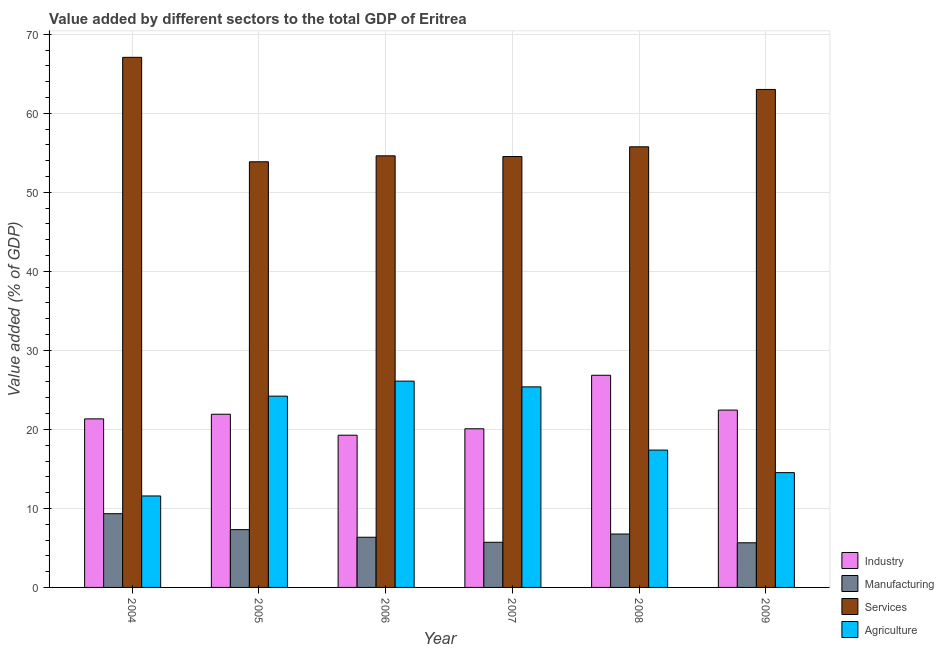How many different coloured bars are there?
Provide a short and direct response. 4. Are the number of bars per tick equal to the number of legend labels?
Offer a terse response. Yes. Are the number of bars on each tick of the X-axis equal?
Your response must be concise. Yes. What is the label of the 2nd group of bars from the left?
Give a very brief answer. 2005. What is the value added by manufacturing sector in 2006?
Your answer should be very brief. 6.35. Across all years, what is the maximum value added by manufacturing sector?
Make the answer very short. 9.33. Across all years, what is the minimum value added by manufacturing sector?
Your answer should be compact. 5.65. In which year was the value added by manufacturing sector minimum?
Offer a very short reply. 2009. What is the total value added by services sector in the graph?
Your answer should be very brief. 348.92. What is the difference between the value added by services sector in 2004 and that in 2005?
Offer a terse response. 13.22. What is the difference between the value added by agricultural sector in 2008 and the value added by industrial sector in 2009?
Make the answer very short. 2.85. What is the average value added by manufacturing sector per year?
Offer a very short reply. 6.85. In how many years, is the value added by industrial sector greater than 52 %?
Offer a very short reply. 0. What is the ratio of the value added by services sector in 2006 to that in 2008?
Your answer should be compact. 0.98. Is the value added by industrial sector in 2005 less than that in 2009?
Offer a terse response. Yes. Is the difference between the value added by agricultural sector in 2004 and 2005 greater than the difference between the value added by industrial sector in 2004 and 2005?
Ensure brevity in your answer.  No. What is the difference between the highest and the second highest value added by manufacturing sector?
Your answer should be very brief. 2.02. What is the difference between the highest and the lowest value added by services sector?
Offer a very short reply. 13.22. In how many years, is the value added by services sector greater than the average value added by services sector taken over all years?
Ensure brevity in your answer.  2. Is the sum of the value added by industrial sector in 2006 and 2009 greater than the maximum value added by manufacturing sector across all years?
Provide a short and direct response. Yes. Is it the case that in every year, the sum of the value added by agricultural sector and value added by industrial sector is greater than the sum of value added by manufacturing sector and value added by services sector?
Ensure brevity in your answer.  No. What does the 2nd bar from the left in 2007 represents?
Your response must be concise. Manufacturing. What does the 1st bar from the right in 2004 represents?
Provide a succinct answer. Agriculture. Is it the case that in every year, the sum of the value added by industrial sector and value added by manufacturing sector is greater than the value added by services sector?
Offer a terse response. No. How many bars are there?
Make the answer very short. 24. How many years are there in the graph?
Keep it short and to the point. 6. What is the difference between two consecutive major ticks on the Y-axis?
Provide a short and direct response. 10. Are the values on the major ticks of Y-axis written in scientific E-notation?
Ensure brevity in your answer.  No. Does the graph contain grids?
Your response must be concise. Yes. How are the legend labels stacked?
Your answer should be compact. Vertical. What is the title of the graph?
Give a very brief answer. Value added by different sectors to the total GDP of Eritrea. Does "France" appear as one of the legend labels in the graph?
Your answer should be very brief. No. What is the label or title of the X-axis?
Your answer should be compact. Year. What is the label or title of the Y-axis?
Keep it short and to the point. Value added (% of GDP). What is the Value added (% of GDP) of Industry in 2004?
Offer a very short reply. 21.33. What is the Value added (% of GDP) of Manufacturing in 2004?
Give a very brief answer. 9.33. What is the Value added (% of GDP) in Services in 2004?
Offer a very short reply. 67.09. What is the Value added (% of GDP) in Agriculture in 2004?
Give a very brief answer. 11.58. What is the Value added (% of GDP) of Industry in 2005?
Your response must be concise. 21.92. What is the Value added (% of GDP) in Manufacturing in 2005?
Your answer should be compact. 7.31. What is the Value added (% of GDP) of Services in 2005?
Your answer should be very brief. 53.87. What is the Value added (% of GDP) in Agriculture in 2005?
Your answer should be very brief. 24.21. What is the Value added (% of GDP) in Industry in 2006?
Offer a very short reply. 19.27. What is the Value added (% of GDP) in Manufacturing in 2006?
Provide a succinct answer. 6.35. What is the Value added (% of GDP) of Services in 2006?
Provide a short and direct response. 54.63. What is the Value added (% of GDP) in Agriculture in 2006?
Give a very brief answer. 26.11. What is the Value added (% of GDP) in Industry in 2007?
Ensure brevity in your answer.  20.08. What is the Value added (% of GDP) of Manufacturing in 2007?
Provide a succinct answer. 5.71. What is the Value added (% of GDP) of Services in 2007?
Offer a terse response. 54.54. What is the Value added (% of GDP) in Agriculture in 2007?
Provide a succinct answer. 25.38. What is the Value added (% of GDP) in Industry in 2008?
Your answer should be very brief. 26.85. What is the Value added (% of GDP) of Manufacturing in 2008?
Your answer should be compact. 6.76. What is the Value added (% of GDP) in Services in 2008?
Make the answer very short. 55.77. What is the Value added (% of GDP) of Agriculture in 2008?
Provide a short and direct response. 17.38. What is the Value added (% of GDP) of Industry in 2009?
Offer a terse response. 22.44. What is the Value added (% of GDP) of Manufacturing in 2009?
Offer a very short reply. 5.65. What is the Value added (% of GDP) of Services in 2009?
Keep it short and to the point. 63.03. What is the Value added (% of GDP) in Agriculture in 2009?
Offer a terse response. 14.53. Across all years, what is the maximum Value added (% of GDP) of Industry?
Your response must be concise. 26.85. Across all years, what is the maximum Value added (% of GDP) of Manufacturing?
Offer a terse response. 9.33. Across all years, what is the maximum Value added (% of GDP) of Services?
Provide a short and direct response. 67.09. Across all years, what is the maximum Value added (% of GDP) of Agriculture?
Your answer should be compact. 26.11. Across all years, what is the minimum Value added (% of GDP) of Industry?
Offer a very short reply. 19.27. Across all years, what is the minimum Value added (% of GDP) of Manufacturing?
Your answer should be very brief. 5.65. Across all years, what is the minimum Value added (% of GDP) of Services?
Offer a very short reply. 53.87. Across all years, what is the minimum Value added (% of GDP) of Agriculture?
Make the answer very short. 11.58. What is the total Value added (% of GDP) of Industry in the graph?
Offer a very short reply. 131.89. What is the total Value added (% of GDP) in Manufacturing in the graph?
Ensure brevity in your answer.  41.12. What is the total Value added (% of GDP) of Services in the graph?
Your answer should be very brief. 348.92. What is the total Value added (% of GDP) in Agriculture in the graph?
Provide a short and direct response. 119.19. What is the difference between the Value added (% of GDP) of Industry in 2004 and that in 2005?
Ensure brevity in your answer.  -0.59. What is the difference between the Value added (% of GDP) in Manufacturing in 2004 and that in 2005?
Offer a very short reply. 2.02. What is the difference between the Value added (% of GDP) in Services in 2004 and that in 2005?
Provide a succinct answer. 13.22. What is the difference between the Value added (% of GDP) of Agriculture in 2004 and that in 2005?
Give a very brief answer. -12.63. What is the difference between the Value added (% of GDP) of Industry in 2004 and that in 2006?
Your answer should be very brief. 2.07. What is the difference between the Value added (% of GDP) in Manufacturing in 2004 and that in 2006?
Make the answer very short. 2.98. What is the difference between the Value added (% of GDP) of Services in 2004 and that in 2006?
Keep it short and to the point. 12.47. What is the difference between the Value added (% of GDP) of Agriculture in 2004 and that in 2006?
Provide a short and direct response. -14.53. What is the difference between the Value added (% of GDP) of Industry in 2004 and that in 2007?
Your response must be concise. 1.25. What is the difference between the Value added (% of GDP) in Manufacturing in 2004 and that in 2007?
Your response must be concise. 3.62. What is the difference between the Value added (% of GDP) in Services in 2004 and that in 2007?
Your response must be concise. 12.55. What is the difference between the Value added (% of GDP) of Agriculture in 2004 and that in 2007?
Your response must be concise. -13.81. What is the difference between the Value added (% of GDP) in Industry in 2004 and that in 2008?
Make the answer very short. -5.52. What is the difference between the Value added (% of GDP) in Manufacturing in 2004 and that in 2008?
Your answer should be very brief. 2.57. What is the difference between the Value added (% of GDP) of Services in 2004 and that in 2008?
Your answer should be very brief. 11.32. What is the difference between the Value added (% of GDP) of Agriculture in 2004 and that in 2008?
Give a very brief answer. -5.81. What is the difference between the Value added (% of GDP) of Industry in 2004 and that in 2009?
Your answer should be compact. -1.11. What is the difference between the Value added (% of GDP) in Manufacturing in 2004 and that in 2009?
Keep it short and to the point. 3.68. What is the difference between the Value added (% of GDP) of Services in 2004 and that in 2009?
Give a very brief answer. 4.06. What is the difference between the Value added (% of GDP) of Agriculture in 2004 and that in 2009?
Provide a short and direct response. -2.95. What is the difference between the Value added (% of GDP) in Industry in 2005 and that in 2006?
Your response must be concise. 2.65. What is the difference between the Value added (% of GDP) in Manufacturing in 2005 and that in 2006?
Your answer should be very brief. 0.96. What is the difference between the Value added (% of GDP) in Services in 2005 and that in 2006?
Make the answer very short. -0.75. What is the difference between the Value added (% of GDP) of Agriculture in 2005 and that in 2006?
Your answer should be very brief. -1.9. What is the difference between the Value added (% of GDP) in Industry in 2005 and that in 2007?
Give a very brief answer. 1.84. What is the difference between the Value added (% of GDP) of Manufacturing in 2005 and that in 2007?
Your answer should be very brief. 1.6. What is the difference between the Value added (% of GDP) of Services in 2005 and that in 2007?
Keep it short and to the point. -0.67. What is the difference between the Value added (% of GDP) in Agriculture in 2005 and that in 2007?
Ensure brevity in your answer.  -1.17. What is the difference between the Value added (% of GDP) in Industry in 2005 and that in 2008?
Provide a short and direct response. -4.93. What is the difference between the Value added (% of GDP) of Manufacturing in 2005 and that in 2008?
Ensure brevity in your answer.  0.55. What is the difference between the Value added (% of GDP) in Services in 2005 and that in 2008?
Provide a short and direct response. -1.89. What is the difference between the Value added (% of GDP) in Agriculture in 2005 and that in 2008?
Provide a succinct answer. 6.83. What is the difference between the Value added (% of GDP) of Industry in 2005 and that in 2009?
Ensure brevity in your answer.  -0.53. What is the difference between the Value added (% of GDP) of Manufacturing in 2005 and that in 2009?
Offer a terse response. 1.66. What is the difference between the Value added (% of GDP) in Services in 2005 and that in 2009?
Make the answer very short. -9.16. What is the difference between the Value added (% of GDP) in Agriculture in 2005 and that in 2009?
Give a very brief answer. 9.68. What is the difference between the Value added (% of GDP) in Industry in 2006 and that in 2007?
Your answer should be very brief. -0.81. What is the difference between the Value added (% of GDP) in Manufacturing in 2006 and that in 2007?
Your response must be concise. 0.64. What is the difference between the Value added (% of GDP) in Services in 2006 and that in 2007?
Give a very brief answer. 0.09. What is the difference between the Value added (% of GDP) in Agriculture in 2006 and that in 2007?
Your answer should be very brief. 0.73. What is the difference between the Value added (% of GDP) of Industry in 2006 and that in 2008?
Provide a short and direct response. -7.58. What is the difference between the Value added (% of GDP) in Manufacturing in 2006 and that in 2008?
Your response must be concise. -0.41. What is the difference between the Value added (% of GDP) in Services in 2006 and that in 2008?
Ensure brevity in your answer.  -1.14. What is the difference between the Value added (% of GDP) of Agriculture in 2006 and that in 2008?
Offer a very short reply. 8.73. What is the difference between the Value added (% of GDP) of Industry in 2006 and that in 2009?
Your answer should be very brief. -3.18. What is the difference between the Value added (% of GDP) of Manufacturing in 2006 and that in 2009?
Your answer should be compact. 0.7. What is the difference between the Value added (% of GDP) in Services in 2006 and that in 2009?
Provide a succinct answer. -8.4. What is the difference between the Value added (% of GDP) of Agriculture in 2006 and that in 2009?
Offer a very short reply. 11.58. What is the difference between the Value added (% of GDP) in Industry in 2007 and that in 2008?
Provide a succinct answer. -6.77. What is the difference between the Value added (% of GDP) in Manufacturing in 2007 and that in 2008?
Provide a succinct answer. -1.04. What is the difference between the Value added (% of GDP) in Services in 2007 and that in 2008?
Ensure brevity in your answer.  -1.23. What is the difference between the Value added (% of GDP) in Agriculture in 2007 and that in 2008?
Your response must be concise. 8. What is the difference between the Value added (% of GDP) in Industry in 2007 and that in 2009?
Make the answer very short. -2.37. What is the difference between the Value added (% of GDP) of Manufacturing in 2007 and that in 2009?
Make the answer very short. 0.06. What is the difference between the Value added (% of GDP) in Services in 2007 and that in 2009?
Offer a very short reply. -8.49. What is the difference between the Value added (% of GDP) in Agriculture in 2007 and that in 2009?
Give a very brief answer. 10.85. What is the difference between the Value added (% of GDP) in Industry in 2008 and that in 2009?
Make the answer very short. 4.41. What is the difference between the Value added (% of GDP) in Manufacturing in 2008 and that in 2009?
Provide a succinct answer. 1.11. What is the difference between the Value added (% of GDP) of Services in 2008 and that in 2009?
Your response must be concise. -7.26. What is the difference between the Value added (% of GDP) of Agriculture in 2008 and that in 2009?
Give a very brief answer. 2.85. What is the difference between the Value added (% of GDP) in Industry in 2004 and the Value added (% of GDP) in Manufacturing in 2005?
Offer a terse response. 14.02. What is the difference between the Value added (% of GDP) in Industry in 2004 and the Value added (% of GDP) in Services in 2005?
Give a very brief answer. -32.54. What is the difference between the Value added (% of GDP) in Industry in 2004 and the Value added (% of GDP) in Agriculture in 2005?
Your answer should be very brief. -2.88. What is the difference between the Value added (% of GDP) of Manufacturing in 2004 and the Value added (% of GDP) of Services in 2005?
Offer a terse response. -44.54. What is the difference between the Value added (% of GDP) of Manufacturing in 2004 and the Value added (% of GDP) of Agriculture in 2005?
Provide a succinct answer. -14.88. What is the difference between the Value added (% of GDP) in Services in 2004 and the Value added (% of GDP) in Agriculture in 2005?
Offer a terse response. 42.88. What is the difference between the Value added (% of GDP) of Industry in 2004 and the Value added (% of GDP) of Manufacturing in 2006?
Your answer should be compact. 14.98. What is the difference between the Value added (% of GDP) of Industry in 2004 and the Value added (% of GDP) of Services in 2006?
Ensure brevity in your answer.  -33.29. What is the difference between the Value added (% of GDP) of Industry in 2004 and the Value added (% of GDP) of Agriculture in 2006?
Your answer should be very brief. -4.78. What is the difference between the Value added (% of GDP) in Manufacturing in 2004 and the Value added (% of GDP) in Services in 2006?
Offer a very short reply. -45.29. What is the difference between the Value added (% of GDP) in Manufacturing in 2004 and the Value added (% of GDP) in Agriculture in 2006?
Your response must be concise. -16.78. What is the difference between the Value added (% of GDP) in Services in 2004 and the Value added (% of GDP) in Agriculture in 2006?
Your answer should be compact. 40.98. What is the difference between the Value added (% of GDP) of Industry in 2004 and the Value added (% of GDP) of Manufacturing in 2007?
Provide a succinct answer. 15.62. What is the difference between the Value added (% of GDP) in Industry in 2004 and the Value added (% of GDP) in Services in 2007?
Offer a terse response. -33.2. What is the difference between the Value added (% of GDP) of Industry in 2004 and the Value added (% of GDP) of Agriculture in 2007?
Give a very brief answer. -4.05. What is the difference between the Value added (% of GDP) of Manufacturing in 2004 and the Value added (% of GDP) of Services in 2007?
Ensure brevity in your answer.  -45.2. What is the difference between the Value added (% of GDP) of Manufacturing in 2004 and the Value added (% of GDP) of Agriculture in 2007?
Ensure brevity in your answer.  -16.05. What is the difference between the Value added (% of GDP) of Services in 2004 and the Value added (% of GDP) of Agriculture in 2007?
Give a very brief answer. 41.71. What is the difference between the Value added (% of GDP) in Industry in 2004 and the Value added (% of GDP) in Manufacturing in 2008?
Provide a succinct answer. 14.57. What is the difference between the Value added (% of GDP) in Industry in 2004 and the Value added (% of GDP) in Services in 2008?
Your response must be concise. -34.43. What is the difference between the Value added (% of GDP) of Industry in 2004 and the Value added (% of GDP) of Agriculture in 2008?
Provide a short and direct response. 3.95. What is the difference between the Value added (% of GDP) in Manufacturing in 2004 and the Value added (% of GDP) in Services in 2008?
Make the answer very short. -46.43. What is the difference between the Value added (% of GDP) in Manufacturing in 2004 and the Value added (% of GDP) in Agriculture in 2008?
Offer a very short reply. -8.05. What is the difference between the Value added (% of GDP) of Services in 2004 and the Value added (% of GDP) of Agriculture in 2008?
Keep it short and to the point. 49.71. What is the difference between the Value added (% of GDP) of Industry in 2004 and the Value added (% of GDP) of Manufacturing in 2009?
Provide a short and direct response. 15.68. What is the difference between the Value added (% of GDP) in Industry in 2004 and the Value added (% of GDP) in Services in 2009?
Your answer should be very brief. -41.69. What is the difference between the Value added (% of GDP) in Industry in 2004 and the Value added (% of GDP) in Agriculture in 2009?
Your answer should be compact. 6.8. What is the difference between the Value added (% of GDP) of Manufacturing in 2004 and the Value added (% of GDP) of Services in 2009?
Offer a very short reply. -53.69. What is the difference between the Value added (% of GDP) of Manufacturing in 2004 and the Value added (% of GDP) of Agriculture in 2009?
Give a very brief answer. -5.2. What is the difference between the Value added (% of GDP) of Services in 2004 and the Value added (% of GDP) of Agriculture in 2009?
Your response must be concise. 52.56. What is the difference between the Value added (% of GDP) of Industry in 2005 and the Value added (% of GDP) of Manufacturing in 2006?
Your answer should be compact. 15.57. What is the difference between the Value added (% of GDP) of Industry in 2005 and the Value added (% of GDP) of Services in 2006?
Your response must be concise. -32.71. What is the difference between the Value added (% of GDP) of Industry in 2005 and the Value added (% of GDP) of Agriculture in 2006?
Provide a succinct answer. -4.19. What is the difference between the Value added (% of GDP) in Manufacturing in 2005 and the Value added (% of GDP) in Services in 2006?
Your response must be concise. -47.31. What is the difference between the Value added (% of GDP) of Manufacturing in 2005 and the Value added (% of GDP) of Agriculture in 2006?
Give a very brief answer. -18.79. What is the difference between the Value added (% of GDP) of Services in 2005 and the Value added (% of GDP) of Agriculture in 2006?
Make the answer very short. 27.76. What is the difference between the Value added (% of GDP) of Industry in 2005 and the Value added (% of GDP) of Manufacturing in 2007?
Your answer should be compact. 16.2. What is the difference between the Value added (% of GDP) in Industry in 2005 and the Value added (% of GDP) in Services in 2007?
Make the answer very short. -32.62. What is the difference between the Value added (% of GDP) in Industry in 2005 and the Value added (% of GDP) in Agriculture in 2007?
Your answer should be compact. -3.46. What is the difference between the Value added (% of GDP) in Manufacturing in 2005 and the Value added (% of GDP) in Services in 2007?
Keep it short and to the point. -47.22. What is the difference between the Value added (% of GDP) of Manufacturing in 2005 and the Value added (% of GDP) of Agriculture in 2007?
Give a very brief answer. -18.07. What is the difference between the Value added (% of GDP) of Services in 2005 and the Value added (% of GDP) of Agriculture in 2007?
Provide a short and direct response. 28.49. What is the difference between the Value added (% of GDP) in Industry in 2005 and the Value added (% of GDP) in Manufacturing in 2008?
Your response must be concise. 15.16. What is the difference between the Value added (% of GDP) of Industry in 2005 and the Value added (% of GDP) of Services in 2008?
Give a very brief answer. -33.85. What is the difference between the Value added (% of GDP) in Industry in 2005 and the Value added (% of GDP) in Agriculture in 2008?
Your answer should be compact. 4.54. What is the difference between the Value added (% of GDP) of Manufacturing in 2005 and the Value added (% of GDP) of Services in 2008?
Provide a succinct answer. -48.45. What is the difference between the Value added (% of GDP) of Manufacturing in 2005 and the Value added (% of GDP) of Agriculture in 2008?
Provide a succinct answer. -10.07. What is the difference between the Value added (% of GDP) of Services in 2005 and the Value added (% of GDP) of Agriculture in 2008?
Your response must be concise. 36.49. What is the difference between the Value added (% of GDP) in Industry in 2005 and the Value added (% of GDP) in Manufacturing in 2009?
Offer a terse response. 16.27. What is the difference between the Value added (% of GDP) in Industry in 2005 and the Value added (% of GDP) in Services in 2009?
Your answer should be very brief. -41.11. What is the difference between the Value added (% of GDP) of Industry in 2005 and the Value added (% of GDP) of Agriculture in 2009?
Ensure brevity in your answer.  7.39. What is the difference between the Value added (% of GDP) of Manufacturing in 2005 and the Value added (% of GDP) of Services in 2009?
Give a very brief answer. -55.71. What is the difference between the Value added (% of GDP) of Manufacturing in 2005 and the Value added (% of GDP) of Agriculture in 2009?
Offer a very short reply. -7.21. What is the difference between the Value added (% of GDP) of Services in 2005 and the Value added (% of GDP) of Agriculture in 2009?
Make the answer very short. 39.34. What is the difference between the Value added (% of GDP) in Industry in 2006 and the Value added (% of GDP) in Manufacturing in 2007?
Your answer should be compact. 13.55. What is the difference between the Value added (% of GDP) in Industry in 2006 and the Value added (% of GDP) in Services in 2007?
Give a very brief answer. -35.27. What is the difference between the Value added (% of GDP) in Industry in 2006 and the Value added (% of GDP) in Agriculture in 2007?
Your answer should be very brief. -6.12. What is the difference between the Value added (% of GDP) of Manufacturing in 2006 and the Value added (% of GDP) of Services in 2007?
Your response must be concise. -48.19. What is the difference between the Value added (% of GDP) in Manufacturing in 2006 and the Value added (% of GDP) in Agriculture in 2007?
Your response must be concise. -19.03. What is the difference between the Value added (% of GDP) of Services in 2006 and the Value added (% of GDP) of Agriculture in 2007?
Ensure brevity in your answer.  29.24. What is the difference between the Value added (% of GDP) in Industry in 2006 and the Value added (% of GDP) in Manufacturing in 2008?
Make the answer very short. 12.51. What is the difference between the Value added (% of GDP) of Industry in 2006 and the Value added (% of GDP) of Services in 2008?
Ensure brevity in your answer.  -36.5. What is the difference between the Value added (% of GDP) in Industry in 2006 and the Value added (% of GDP) in Agriculture in 2008?
Make the answer very short. 1.88. What is the difference between the Value added (% of GDP) in Manufacturing in 2006 and the Value added (% of GDP) in Services in 2008?
Your answer should be compact. -49.41. What is the difference between the Value added (% of GDP) in Manufacturing in 2006 and the Value added (% of GDP) in Agriculture in 2008?
Offer a very short reply. -11.03. What is the difference between the Value added (% of GDP) in Services in 2006 and the Value added (% of GDP) in Agriculture in 2008?
Offer a very short reply. 37.24. What is the difference between the Value added (% of GDP) of Industry in 2006 and the Value added (% of GDP) of Manufacturing in 2009?
Ensure brevity in your answer.  13.62. What is the difference between the Value added (% of GDP) in Industry in 2006 and the Value added (% of GDP) in Services in 2009?
Your answer should be compact. -43.76. What is the difference between the Value added (% of GDP) in Industry in 2006 and the Value added (% of GDP) in Agriculture in 2009?
Provide a succinct answer. 4.74. What is the difference between the Value added (% of GDP) of Manufacturing in 2006 and the Value added (% of GDP) of Services in 2009?
Make the answer very short. -56.67. What is the difference between the Value added (% of GDP) of Manufacturing in 2006 and the Value added (% of GDP) of Agriculture in 2009?
Keep it short and to the point. -8.18. What is the difference between the Value added (% of GDP) of Services in 2006 and the Value added (% of GDP) of Agriculture in 2009?
Ensure brevity in your answer.  40.1. What is the difference between the Value added (% of GDP) in Industry in 2007 and the Value added (% of GDP) in Manufacturing in 2008?
Your response must be concise. 13.32. What is the difference between the Value added (% of GDP) in Industry in 2007 and the Value added (% of GDP) in Services in 2008?
Your answer should be compact. -35.69. What is the difference between the Value added (% of GDP) of Industry in 2007 and the Value added (% of GDP) of Agriculture in 2008?
Your answer should be very brief. 2.7. What is the difference between the Value added (% of GDP) in Manufacturing in 2007 and the Value added (% of GDP) in Services in 2008?
Provide a short and direct response. -50.05. What is the difference between the Value added (% of GDP) of Manufacturing in 2007 and the Value added (% of GDP) of Agriculture in 2008?
Offer a very short reply. -11.67. What is the difference between the Value added (% of GDP) of Services in 2007 and the Value added (% of GDP) of Agriculture in 2008?
Your response must be concise. 37.16. What is the difference between the Value added (% of GDP) of Industry in 2007 and the Value added (% of GDP) of Manufacturing in 2009?
Make the answer very short. 14.43. What is the difference between the Value added (% of GDP) of Industry in 2007 and the Value added (% of GDP) of Services in 2009?
Provide a short and direct response. -42.95. What is the difference between the Value added (% of GDP) of Industry in 2007 and the Value added (% of GDP) of Agriculture in 2009?
Ensure brevity in your answer.  5.55. What is the difference between the Value added (% of GDP) in Manufacturing in 2007 and the Value added (% of GDP) in Services in 2009?
Make the answer very short. -57.31. What is the difference between the Value added (% of GDP) in Manufacturing in 2007 and the Value added (% of GDP) in Agriculture in 2009?
Provide a short and direct response. -8.81. What is the difference between the Value added (% of GDP) of Services in 2007 and the Value added (% of GDP) of Agriculture in 2009?
Your answer should be very brief. 40.01. What is the difference between the Value added (% of GDP) in Industry in 2008 and the Value added (% of GDP) in Manufacturing in 2009?
Keep it short and to the point. 21.2. What is the difference between the Value added (% of GDP) in Industry in 2008 and the Value added (% of GDP) in Services in 2009?
Ensure brevity in your answer.  -36.18. What is the difference between the Value added (% of GDP) in Industry in 2008 and the Value added (% of GDP) in Agriculture in 2009?
Provide a succinct answer. 12.32. What is the difference between the Value added (% of GDP) of Manufacturing in 2008 and the Value added (% of GDP) of Services in 2009?
Ensure brevity in your answer.  -56.27. What is the difference between the Value added (% of GDP) of Manufacturing in 2008 and the Value added (% of GDP) of Agriculture in 2009?
Your answer should be compact. -7.77. What is the difference between the Value added (% of GDP) of Services in 2008 and the Value added (% of GDP) of Agriculture in 2009?
Keep it short and to the point. 41.24. What is the average Value added (% of GDP) of Industry per year?
Your response must be concise. 21.98. What is the average Value added (% of GDP) of Manufacturing per year?
Provide a succinct answer. 6.85. What is the average Value added (% of GDP) of Services per year?
Your response must be concise. 58.15. What is the average Value added (% of GDP) in Agriculture per year?
Your answer should be compact. 19.86. In the year 2004, what is the difference between the Value added (% of GDP) in Industry and Value added (% of GDP) in Manufacturing?
Offer a terse response. 12. In the year 2004, what is the difference between the Value added (% of GDP) in Industry and Value added (% of GDP) in Services?
Your answer should be compact. -45.76. In the year 2004, what is the difference between the Value added (% of GDP) of Industry and Value added (% of GDP) of Agriculture?
Your response must be concise. 9.76. In the year 2004, what is the difference between the Value added (% of GDP) of Manufacturing and Value added (% of GDP) of Services?
Your response must be concise. -57.76. In the year 2004, what is the difference between the Value added (% of GDP) of Manufacturing and Value added (% of GDP) of Agriculture?
Ensure brevity in your answer.  -2.24. In the year 2004, what is the difference between the Value added (% of GDP) in Services and Value added (% of GDP) in Agriculture?
Offer a terse response. 55.52. In the year 2005, what is the difference between the Value added (% of GDP) of Industry and Value added (% of GDP) of Manufacturing?
Provide a succinct answer. 14.61. In the year 2005, what is the difference between the Value added (% of GDP) of Industry and Value added (% of GDP) of Services?
Ensure brevity in your answer.  -31.95. In the year 2005, what is the difference between the Value added (% of GDP) of Industry and Value added (% of GDP) of Agriculture?
Make the answer very short. -2.29. In the year 2005, what is the difference between the Value added (% of GDP) in Manufacturing and Value added (% of GDP) in Services?
Make the answer very short. -46.56. In the year 2005, what is the difference between the Value added (% of GDP) of Manufacturing and Value added (% of GDP) of Agriculture?
Ensure brevity in your answer.  -16.89. In the year 2005, what is the difference between the Value added (% of GDP) of Services and Value added (% of GDP) of Agriculture?
Your answer should be very brief. 29.66. In the year 2006, what is the difference between the Value added (% of GDP) of Industry and Value added (% of GDP) of Manufacturing?
Your response must be concise. 12.91. In the year 2006, what is the difference between the Value added (% of GDP) of Industry and Value added (% of GDP) of Services?
Give a very brief answer. -35.36. In the year 2006, what is the difference between the Value added (% of GDP) in Industry and Value added (% of GDP) in Agriculture?
Provide a succinct answer. -6.84. In the year 2006, what is the difference between the Value added (% of GDP) in Manufacturing and Value added (% of GDP) in Services?
Offer a very short reply. -48.27. In the year 2006, what is the difference between the Value added (% of GDP) in Manufacturing and Value added (% of GDP) in Agriculture?
Your answer should be compact. -19.76. In the year 2006, what is the difference between the Value added (% of GDP) of Services and Value added (% of GDP) of Agriculture?
Make the answer very short. 28.52. In the year 2007, what is the difference between the Value added (% of GDP) in Industry and Value added (% of GDP) in Manufacturing?
Keep it short and to the point. 14.36. In the year 2007, what is the difference between the Value added (% of GDP) of Industry and Value added (% of GDP) of Services?
Offer a terse response. -34.46. In the year 2007, what is the difference between the Value added (% of GDP) in Industry and Value added (% of GDP) in Agriculture?
Give a very brief answer. -5.3. In the year 2007, what is the difference between the Value added (% of GDP) of Manufacturing and Value added (% of GDP) of Services?
Make the answer very short. -48.82. In the year 2007, what is the difference between the Value added (% of GDP) in Manufacturing and Value added (% of GDP) in Agriculture?
Your answer should be compact. -19.67. In the year 2007, what is the difference between the Value added (% of GDP) in Services and Value added (% of GDP) in Agriculture?
Your response must be concise. 29.15. In the year 2008, what is the difference between the Value added (% of GDP) of Industry and Value added (% of GDP) of Manufacturing?
Offer a terse response. 20.09. In the year 2008, what is the difference between the Value added (% of GDP) of Industry and Value added (% of GDP) of Services?
Your answer should be compact. -28.92. In the year 2008, what is the difference between the Value added (% of GDP) in Industry and Value added (% of GDP) in Agriculture?
Give a very brief answer. 9.47. In the year 2008, what is the difference between the Value added (% of GDP) in Manufacturing and Value added (% of GDP) in Services?
Your answer should be compact. -49.01. In the year 2008, what is the difference between the Value added (% of GDP) of Manufacturing and Value added (% of GDP) of Agriculture?
Offer a very short reply. -10.62. In the year 2008, what is the difference between the Value added (% of GDP) of Services and Value added (% of GDP) of Agriculture?
Offer a very short reply. 38.38. In the year 2009, what is the difference between the Value added (% of GDP) of Industry and Value added (% of GDP) of Manufacturing?
Provide a succinct answer. 16.79. In the year 2009, what is the difference between the Value added (% of GDP) of Industry and Value added (% of GDP) of Services?
Make the answer very short. -40.58. In the year 2009, what is the difference between the Value added (% of GDP) of Industry and Value added (% of GDP) of Agriculture?
Your answer should be very brief. 7.92. In the year 2009, what is the difference between the Value added (% of GDP) in Manufacturing and Value added (% of GDP) in Services?
Your answer should be very brief. -57.38. In the year 2009, what is the difference between the Value added (% of GDP) of Manufacturing and Value added (% of GDP) of Agriculture?
Offer a terse response. -8.88. In the year 2009, what is the difference between the Value added (% of GDP) in Services and Value added (% of GDP) in Agriculture?
Your answer should be very brief. 48.5. What is the ratio of the Value added (% of GDP) of Industry in 2004 to that in 2005?
Your answer should be very brief. 0.97. What is the ratio of the Value added (% of GDP) in Manufacturing in 2004 to that in 2005?
Provide a succinct answer. 1.28. What is the ratio of the Value added (% of GDP) of Services in 2004 to that in 2005?
Ensure brevity in your answer.  1.25. What is the ratio of the Value added (% of GDP) in Agriculture in 2004 to that in 2005?
Keep it short and to the point. 0.48. What is the ratio of the Value added (% of GDP) in Industry in 2004 to that in 2006?
Give a very brief answer. 1.11. What is the ratio of the Value added (% of GDP) of Manufacturing in 2004 to that in 2006?
Keep it short and to the point. 1.47. What is the ratio of the Value added (% of GDP) of Services in 2004 to that in 2006?
Keep it short and to the point. 1.23. What is the ratio of the Value added (% of GDP) of Agriculture in 2004 to that in 2006?
Your answer should be compact. 0.44. What is the ratio of the Value added (% of GDP) of Industry in 2004 to that in 2007?
Your answer should be very brief. 1.06. What is the ratio of the Value added (% of GDP) of Manufacturing in 2004 to that in 2007?
Keep it short and to the point. 1.63. What is the ratio of the Value added (% of GDP) in Services in 2004 to that in 2007?
Your answer should be very brief. 1.23. What is the ratio of the Value added (% of GDP) of Agriculture in 2004 to that in 2007?
Ensure brevity in your answer.  0.46. What is the ratio of the Value added (% of GDP) of Industry in 2004 to that in 2008?
Provide a succinct answer. 0.79. What is the ratio of the Value added (% of GDP) in Manufacturing in 2004 to that in 2008?
Your answer should be compact. 1.38. What is the ratio of the Value added (% of GDP) in Services in 2004 to that in 2008?
Your answer should be very brief. 1.2. What is the ratio of the Value added (% of GDP) of Agriculture in 2004 to that in 2008?
Give a very brief answer. 0.67. What is the ratio of the Value added (% of GDP) of Industry in 2004 to that in 2009?
Make the answer very short. 0.95. What is the ratio of the Value added (% of GDP) in Manufacturing in 2004 to that in 2009?
Offer a very short reply. 1.65. What is the ratio of the Value added (% of GDP) of Services in 2004 to that in 2009?
Your answer should be very brief. 1.06. What is the ratio of the Value added (% of GDP) in Agriculture in 2004 to that in 2009?
Your response must be concise. 0.8. What is the ratio of the Value added (% of GDP) in Industry in 2005 to that in 2006?
Keep it short and to the point. 1.14. What is the ratio of the Value added (% of GDP) in Manufacturing in 2005 to that in 2006?
Provide a succinct answer. 1.15. What is the ratio of the Value added (% of GDP) in Services in 2005 to that in 2006?
Offer a terse response. 0.99. What is the ratio of the Value added (% of GDP) in Agriculture in 2005 to that in 2006?
Provide a short and direct response. 0.93. What is the ratio of the Value added (% of GDP) in Industry in 2005 to that in 2007?
Your answer should be very brief. 1.09. What is the ratio of the Value added (% of GDP) of Manufacturing in 2005 to that in 2007?
Your answer should be very brief. 1.28. What is the ratio of the Value added (% of GDP) of Agriculture in 2005 to that in 2007?
Provide a succinct answer. 0.95. What is the ratio of the Value added (% of GDP) of Industry in 2005 to that in 2008?
Give a very brief answer. 0.82. What is the ratio of the Value added (% of GDP) of Manufacturing in 2005 to that in 2008?
Keep it short and to the point. 1.08. What is the ratio of the Value added (% of GDP) of Services in 2005 to that in 2008?
Your response must be concise. 0.97. What is the ratio of the Value added (% of GDP) in Agriculture in 2005 to that in 2008?
Ensure brevity in your answer.  1.39. What is the ratio of the Value added (% of GDP) in Industry in 2005 to that in 2009?
Offer a very short reply. 0.98. What is the ratio of the Value added (% of GDP) in Manufacturing in 2005 to that in 2009?
Your answer should be very brief. 1.29. What is the ratio of the Value added (% of GDP) of Services in 2005 to that in 2009?
Offer a terse response. 0.85. What is the ratio of the Value added (% of GDP) in Agriculture in 2005 to that in 2009?
Your response must be concise. 1.67. What is the ratio of the Value added (% of GDP) of Industry in 2006 to that in 2007?
Your answer should be very brief. 0.96. What is the ratio of the Value added (% of GDP) in Manufacturing in 2006 to that in 2007?
Give a very brief answer. 1.11. What is the ratio of the Value added (% of GDP) of Agriculture in 2006 to that in 2007?
Provide a short and direct response. 1.03. What is the ratio of the Value added (% of GDP) of Industry in 2006 to that in 2008?
Your response must be concise. 0.72. What is the ratio of the Value added (% of GDP) in Manufacturing in 2006 to that in 2008?
Provide a short and direct response. 0.94. What is the ratio of the Value added (% of GDP) in Services in 2006 to that in 2008?
Ensure brevity in your answer.  0.98. What is the ratio of the Value added (% of GDP) in Agriculture in 2006 to that in 2008?
Make the answer very short. 1.5. What is the ratio of the Value added (% of GDP) in Industry in 2006 to that in 2009?
Provide a short and direct response. 0.86. What is the ratio of the Value added (% of GDP) of Manufacturing in 2006 to that in 2009?
Offer a very short reply. 1.12. What is the ratio of the Value added (% of GDP) of Services in 2006 to that in 2009?
Your answer should be very brief. 0.87. What is the ratio of the Value added (% of GDP) of Agriculture in 2006 to that in 2009?
Offer a terse response. 1.8. What is the ratio of the Value added (% of GDP) in Industry in 2007 to that in 2008?
Offer a terse response. 0.75. What is the ratio of the Value added (% of GDP) in Manufacturing in 2007 to that in 2008?
Your answer should be compact. 0.85. What is the ratio of the Value added (% of GDP) in Agriculture in 2007 to that in 2008?
Your answer should be compact. 1.46. What is the ratio of the Value added (% of GDP) of Industry in 2007 to that in 2009?
Ensure brevity in your answer.  0.89. What is the ratio of the Value added (% of GDP) of Manufacturing in 2007 to that in 2009?
Your answer should be very brief. 1.01. What is the ratio of the Value added (% of GDP) in Services in 2007 to that in 2009?
Offer a very short reply. 0.87. What is the ratio of the Value added (% of GDP) in Agriculture in 2007 to that in 2009?
Keep it short and to the point. 1.75. What is the ratio of the Value added (% of GDP) in Industry in 2008 to that in 2009?
Make the answer very short. 1.2. What is the ratio of the Value added (% of GDP) in Manufacturing in 2008 to that in 2009?
Your response must be concise. 1.2. What is the ratio of the Value added (% of GDP) of Services in 2008 to that in 2009?
Ensure brevity in your answer.  0.88. What is the ratio of the Value added (% of GDP) of Agriculture in 2008 to that in 2009?
Offer a terse response. 1.2. What is the difference between the highest and the second highest Value added (% of GDP) of Industry?
Offer a very short reply. 4.41. What is the difference between the highest and the second highest Value added (% of GDP) of Manufacturing?
Provide a short and direct response. 2.02. What is the difference between the highest and the second highest Value added (% of GDP) in Services?
Provide a succinct answer. 4.06. What is the difference between the highest and the second highest Value added (% of GDP) in Agriculture?
Provide a succinct answer. 0.73. What is the difference between the highest and the lowest Value added (% of GDP) of Industry?
Your answer should be compact. 7.58. What is the difference between the highest and the lowest Value added (% of GDP) in Manufacturing?
Give a very brief answer. 3.68. What is the difference between the highest and the lowest Value added (% of GDP) of Services?
Your answer should be very brief. 13.22. What is the difference between the highest and the lowest Value added (% of GDP) of Agriculture?
Your answer should be compact. 14.53. 